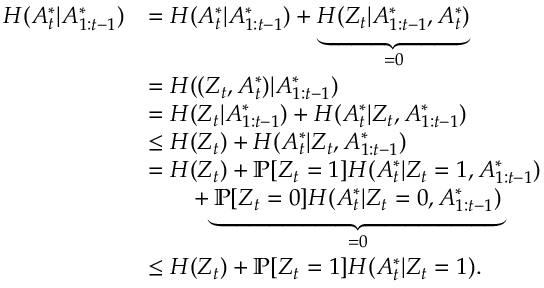Convert formula to latex. <formula><loc_0><loc_0><loc_500><loc_500>\begin{array} { r l } { H ( A _ { t } ^ { * } | A _ { 1 \colon t - 1 } ^ { * } ) } & { = H ( A _ { t } ^ { * } | A _ { 1 \colon t - 1 } ^ { * } ) + \underbrace { H ( Z _ { t } | A _ { 1 \colon t - 1 } ^ { * } , A _ { t } ^ { * } ) } _ { = 0 } } \\ & { = H ( ( Z _ { t } , A _ { t } ^ { * } ) | A _ { 1 \colon t - 1 } ^ { * } ) } \\ & { = H ( Z _ { t } | A _ { 1 \colon t - 1 } ^ { * } ) + H ( A _ { t } ^ { * } | Z _ { t } , A _ { 1 \colon t - 1 } ^ { * } ) } \\ & { \leq H ( Z _ { t } ) + H ( A _ { t } ^ { * } | Z _ { t } , A _ { 1 \colon t - 1 } ^ { * } ) } \\ & { = H ( Z _ { t } ) + \mathbb { P } [ Z _ { t } = 1 ] H ( A _ { t } ^ { * } | Z _ { t } = 1 , A _ { 1 \colon t - 1 } ^ { * } ) } \\ & { \quad + \underbrace { \mathbb { P } [ Z _ { t } = 0 ] H ( A _ { t } ^ { * } | Z _ { t } = 0 , A _ { 1 \colon t - 1 } ^ { * } ) } _ { = 0 } } \\ & { \leq H ( Z _ { t } ) + \mathbb { P } [ Z _ { t } = 1 ] H ( A _ { t } ^ { * } | Z _ { t } = 1 ) . } \end{array}</formula> 